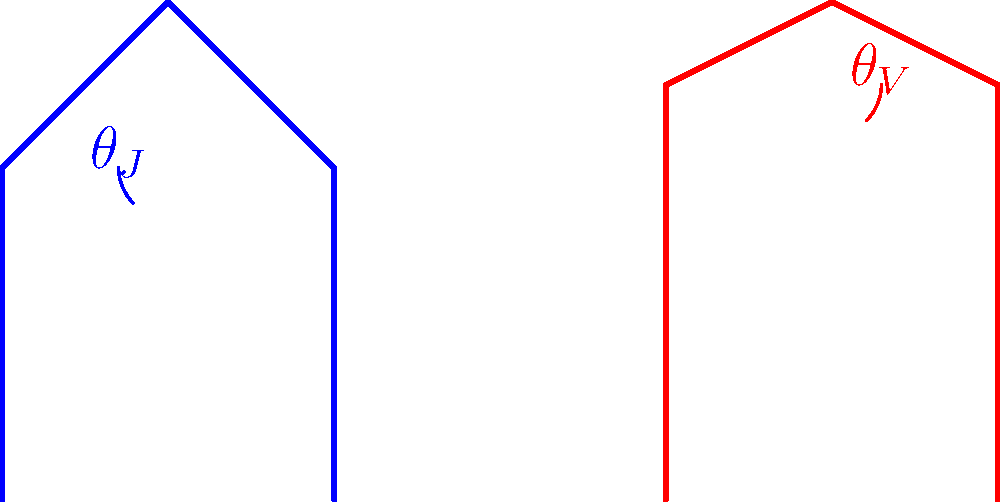In "Coming to America," James Earl Jones portrays King Jaffe Joffer with regal posture, while in "Star Wars," he voices the imposing Darth Vader. Comparing their postures, which character likely has a larger hip angle ($\theta$) when standing, and how might this affect their on-screen presence? To answer this question, let's break down the biomechanics of both characters:

1. King Jaffe Joffer (Coming to America):
   - As a king, Jaffe Joffer likely maintains an upright, dignified posture.
   - This results in a relatively straight back and a smaller hip angle ($\theta_J$).
   - The smaller hip angle contributes to a more erect stance, projecting authority and regality.

2. Darth Vader (Star Wars):
   - Vader's costume includes a heavy suit and helmet, which may affect his posture.
   - To accommodate the weight and maintain balance, Vader likely has a slightly forward-leaning stance.
   - This forward lean would result in a larger hip angle ($\theta_V$).

3. Comparison:
   - $\theta_V > \theta_J$ due to the difference in character physiology and costume.
   - The larger hip angle for Vader contributes to his menacing, looming presence on screen.
   - King Jaffe's smaller hip angle aligns with his regal bearing and upright posture.

4. On-screen presence:
   - Jaffe's posture conveys regality, confidence, and authority through his upright stance.
   - Vader's posture adds to his intimidating presence, making him appear larger and more imposing.

5. Acting technique:
   - James Earl Jones likely adjusted his body language for each role, even though he only voiced Vader.
   - This awareness of posture and its impact on character portrayal demonstrates Jones' versatility as an actor.
Answer: Darth Vader; larger hip angle creates a more imposing presence. 